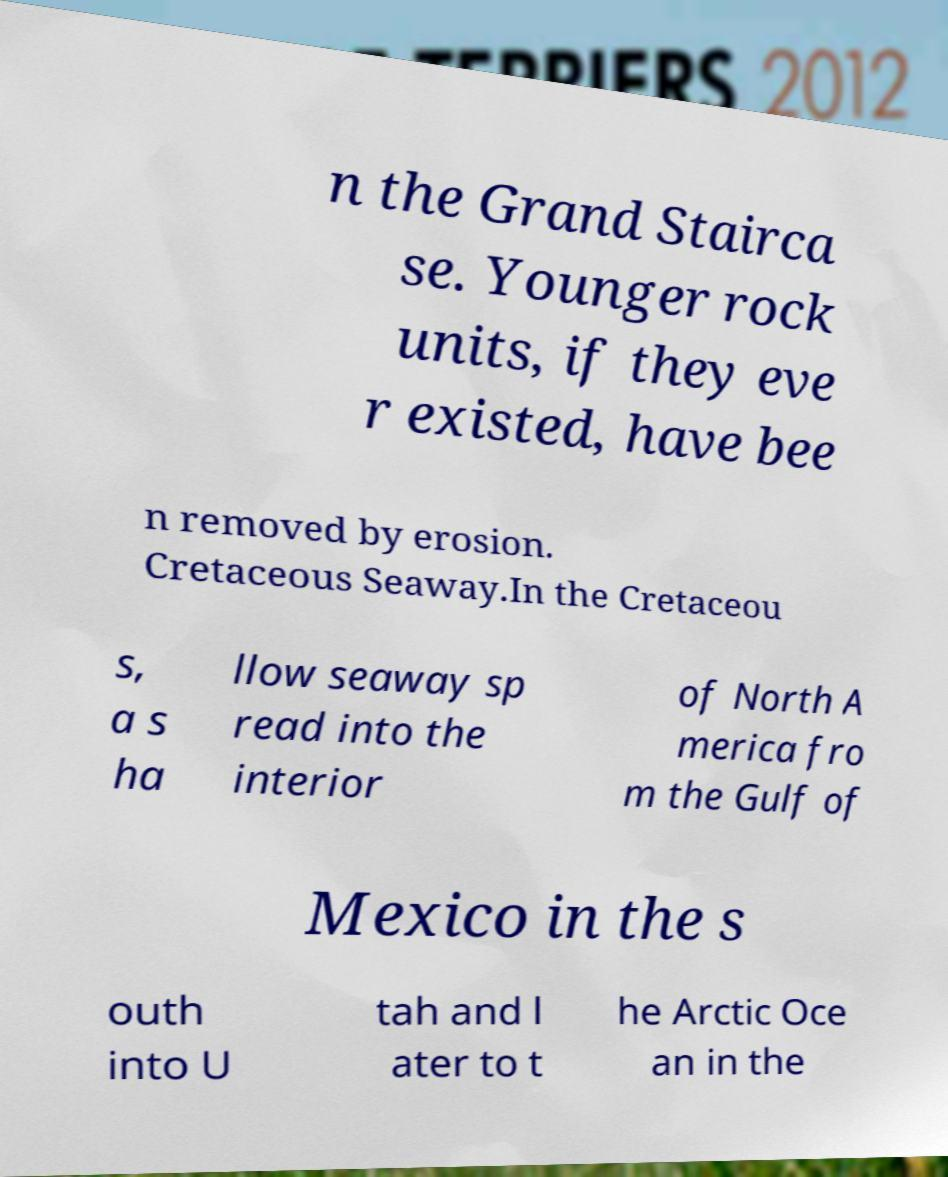I need the written content from this picture converted into text. Can you do that? n the Grand Stairca se. Younger rock units, if they eve r existed, have bee n removed by erosion. Cretaceous Seaway.In the Cretaceou s, a s ha llow seaway sp read into the interior of North A merica fro m the Gulf of Mexico in the s outh into U tah and l ater to t he Arctic Oce an in the 